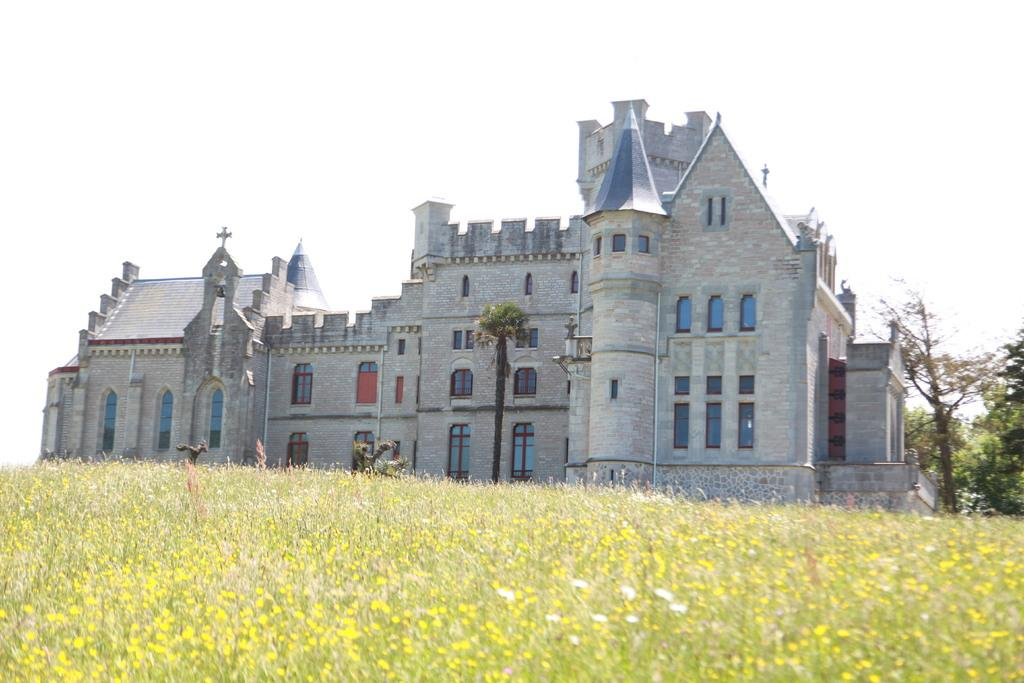What type of structure is present in the image? There is a building in the image. Can you describe the building's appearance? The building has multiple windows. What other natural elements are visible in the image? There are trees and plants in the image. What can be seen in the background of the image? The sky is visible in the background of the image. What type of invention is being demonstrated in the image? There is no invention being demonstrated in the image; it primarily features a building with multiple windows, trees, plants, and the sky in the background. Can you tell me what color the dog's collar is in the image? There are no dogs or collars present in the image. 